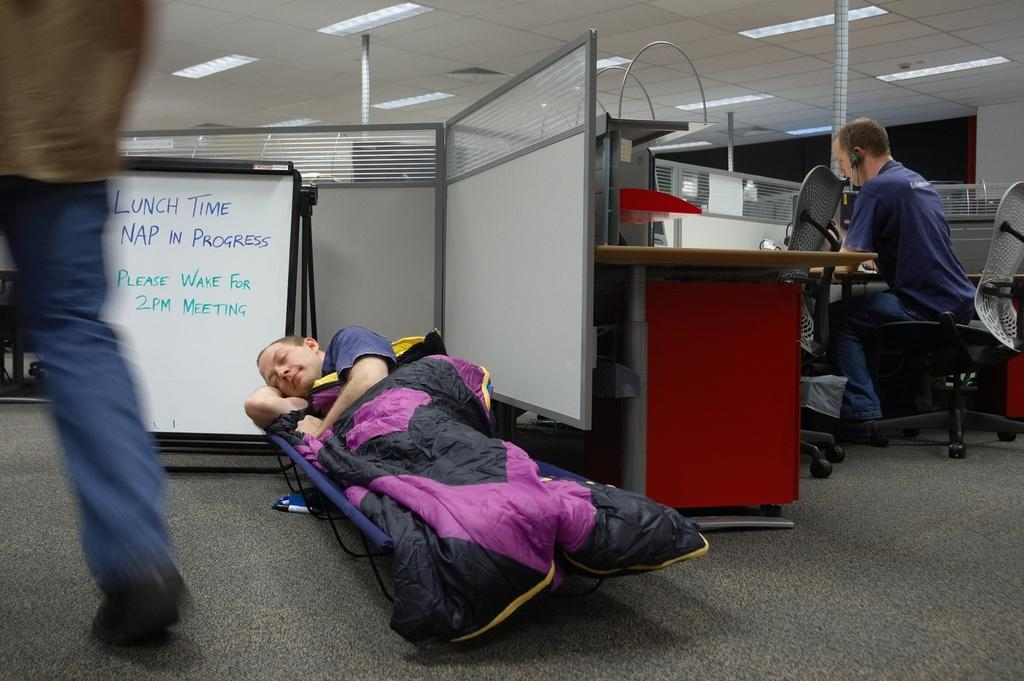How many people are in the image? There are three people in the image. What is the condition of the person on the stretcher? A man is lying on a stretcher with a blanket on him. What is the position of the person sitting in the image? There is a person sitting on a chair. What type of furniture is present in the image? There is a board and a desk in the image. What are the poles used for in the image? The poles are present in the image, but their purpose is not specified. What type of illumination is present in the image? There are lights in the image. Can you describe the unspecified objects in the image? There are some unspecified objects in the image, but their nature is not clear from the provided facts. How does the decision affect the bridge in the image? There is no decision or bridge present in the image. What type of material is the rub used on in the image? There is no rub present in the image. 